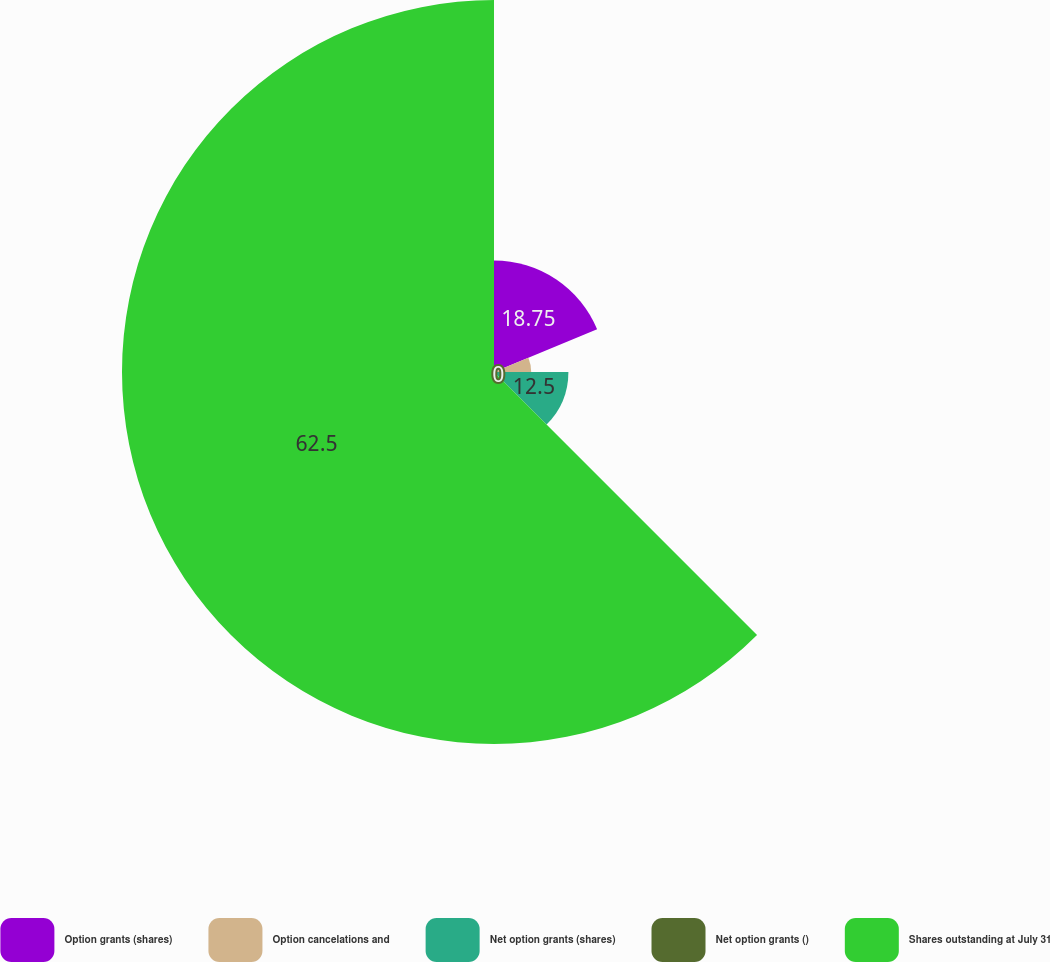Convert chart. <chart><loc_0><loc_0><loc_500><loc_500><pie_chart><fcel>Option grants (shares)<fcel>Option cancelations and<fcel>Net option grants (shares)<fcel>Net option grants ()<fcel>Shares outstanding at July 31<nl><fcel>18.75%<fcel>6.25%<fcel>12.5%<fcel>0.0%<fcel>62.5%<nl></chart> 